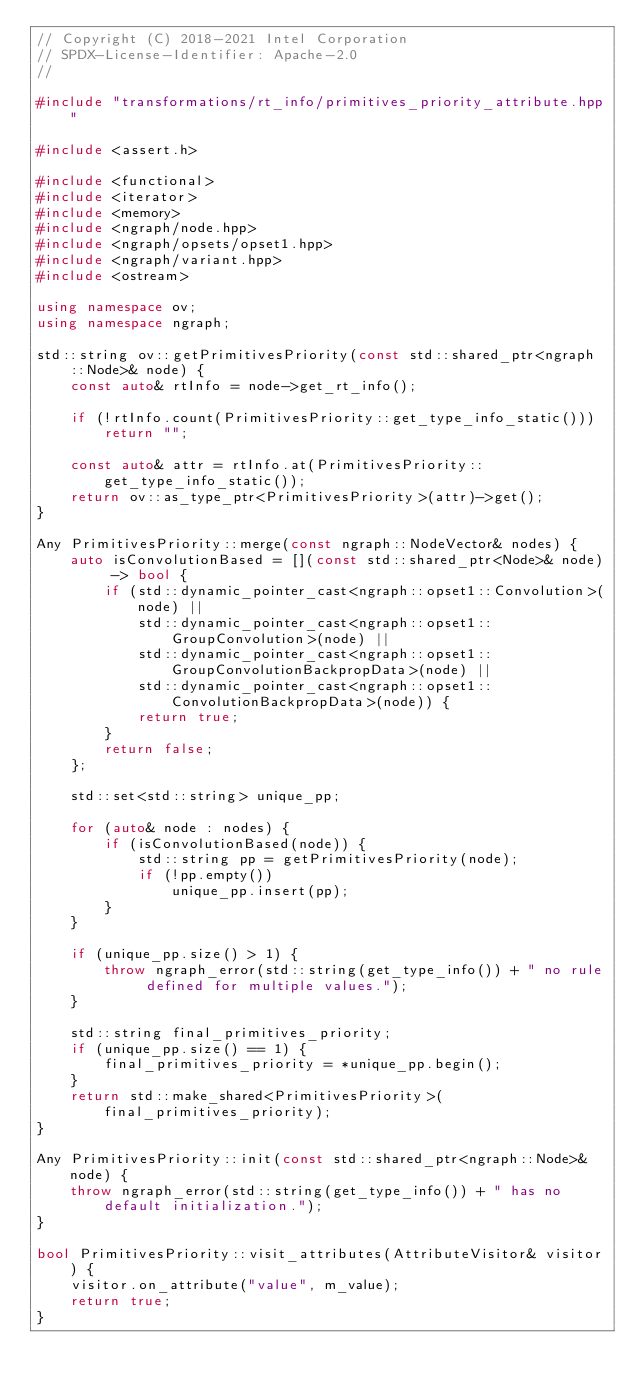Convert code to text. <code><loc_0><loc_0><loc_500><loc_500><_C++_>// Copyright (C) 2018-2021 Intel Corporation
// SPDX-License-Identifier: Apache-2.0
//

#include "transformations/rt_info/primitives_priority_attribute.hpp"

#include <assert.h>

#include <functional>
#include <iterator>
#include <memory>
#include <ngraph/node.hpp>
#include <ngraph/opsets/opset1.hpp>
#include <ngraph/variant.hpp>
#include <ostream>

using namespace ov;
using namespace ngraph;

std::string ov::getPrimitivesPriority(const std::shared_ptr<ngraph::Node>& node) {
    const auto& rtInfo = node->get_rt_info();

    if (!rtInfo.count(PrimitivesPriority::get_type_info_static()))
        return "";

    const auto& attr = rtInfo.at(PrimitivesPriority::get_type_info_static());
    return ov::as_type_ptr<PrimitivesPriority>(attr)->get();
}

Any PrimitivesPriority::merge(const ngraph::NodeVector& nodes) {
    auto isConvolutionBased = [](const std::shared_ptr<Node>& node) -> bool {
        if (std::dynamic_pointer_cast<ngraph::opset1::Convolution>(node) ||
            std::dynamic_pointer_cast<ngraph::opset1::GroupConvolution>(node) ||
            std::dynamic_pointer_cast<ngraph::opset1::GroupConvolutionBackpropData>(node) ||
            std::dynamic_pointer_cast<ngraph::opset1::ConvolutionBackpropData>(node)) {
            return true;
        }
        return false;
    };

    std::set<std::string> unique_pp;

    for (auto& node : nodes) {
        if (isConvolutionBased(node)) {
            std::string pp = getPrimitivesPriority(node);
            if (!pp.empty())
                unique_pp.insert(pp);
        }
    }

    if (unique_pp.size() > 1) {
        throw ngraph_error(std::string(get_type_info()) + " no rule defined for multiple values.");
    }

    std::string final_primitives_priority;
    if (unique_pp.size() == 1) {
        final_primitives_priority = *unique_pp.begin();
    }
    return std::make_shared<PrimitivesPriority>(final_primitives_priority);
}

Any PrimitivesPriority::init(const std::shared_ptr<ngraph::Node>& node) {
    throw ngraph_error(std::string(get_type_info()) + " has no default initialization.");
}

bool PrimitivesPriority::visit_attributes(AttributeVisitor& visitor) {
    visitor.on_attribute("value", m_value);
    return true;
}
</code> 